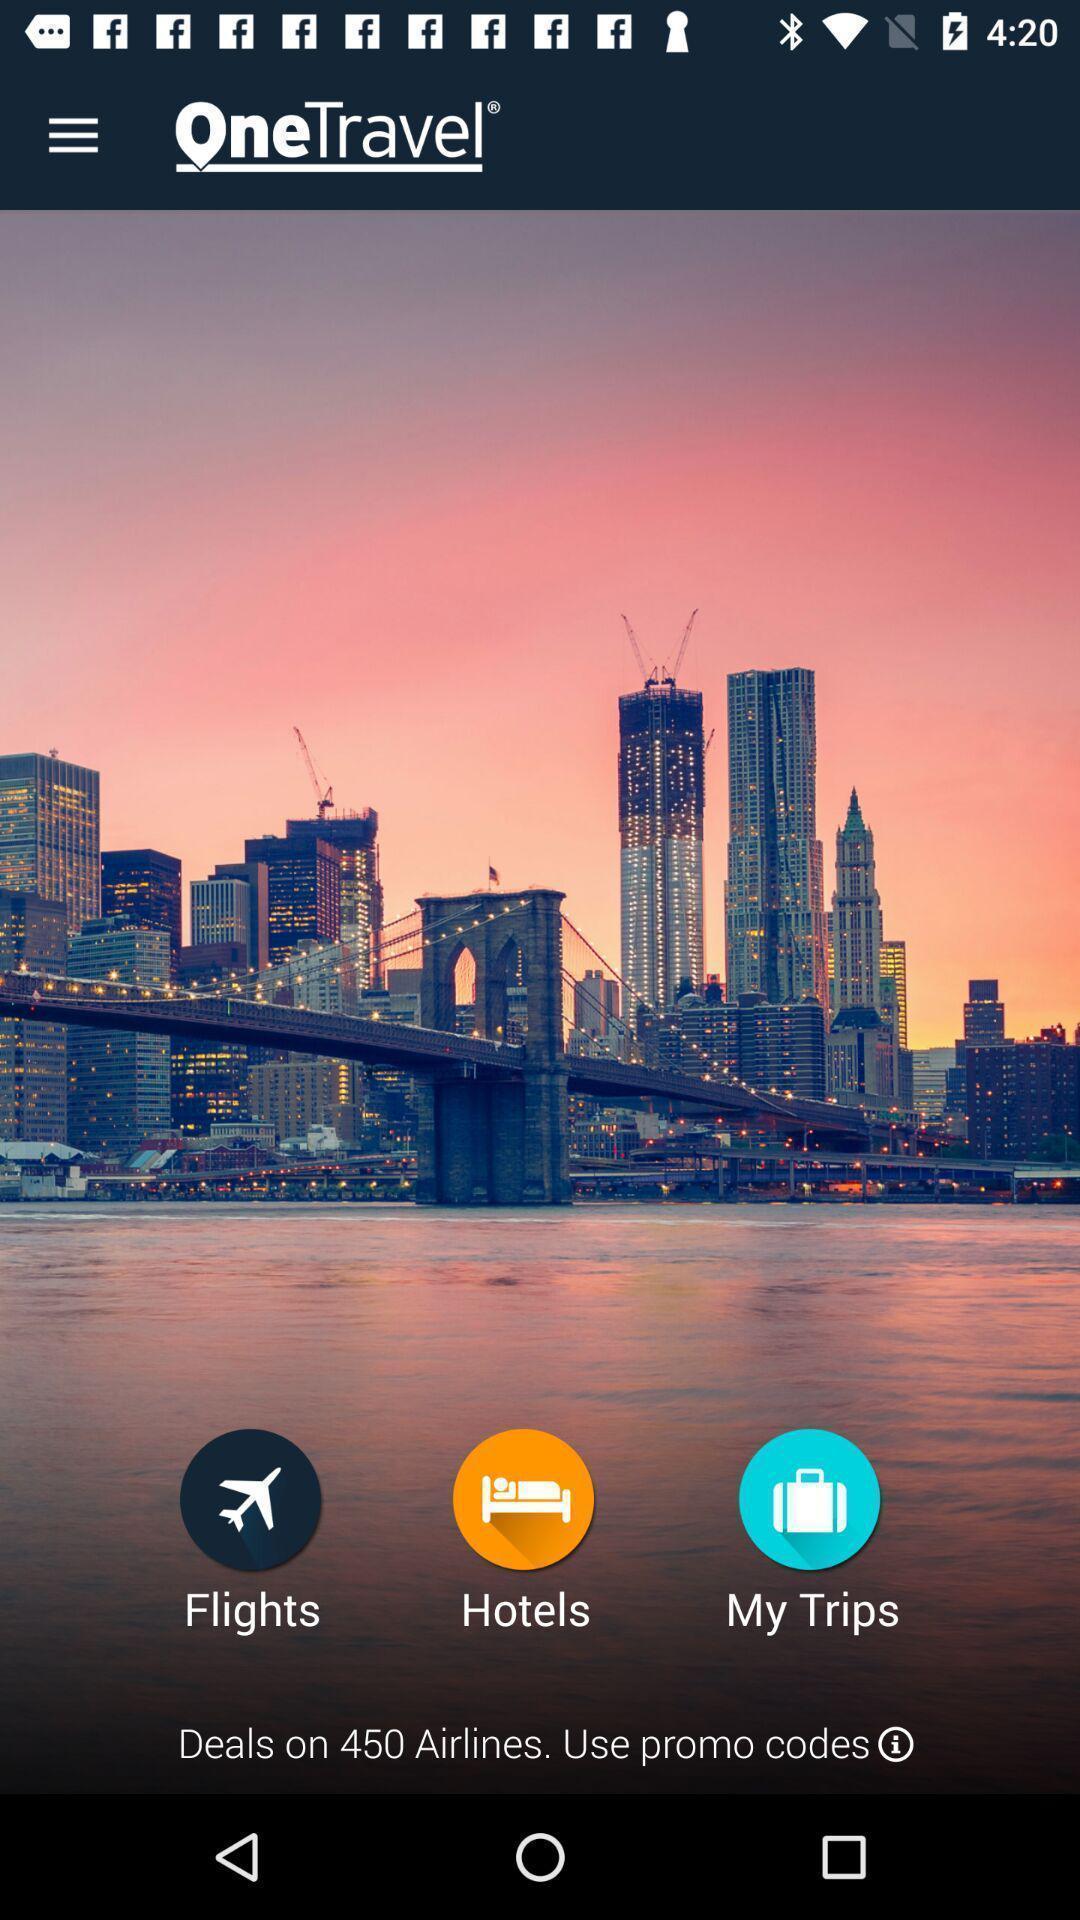Describe the key features of this screenshot. Welcome page of a travelling app. 